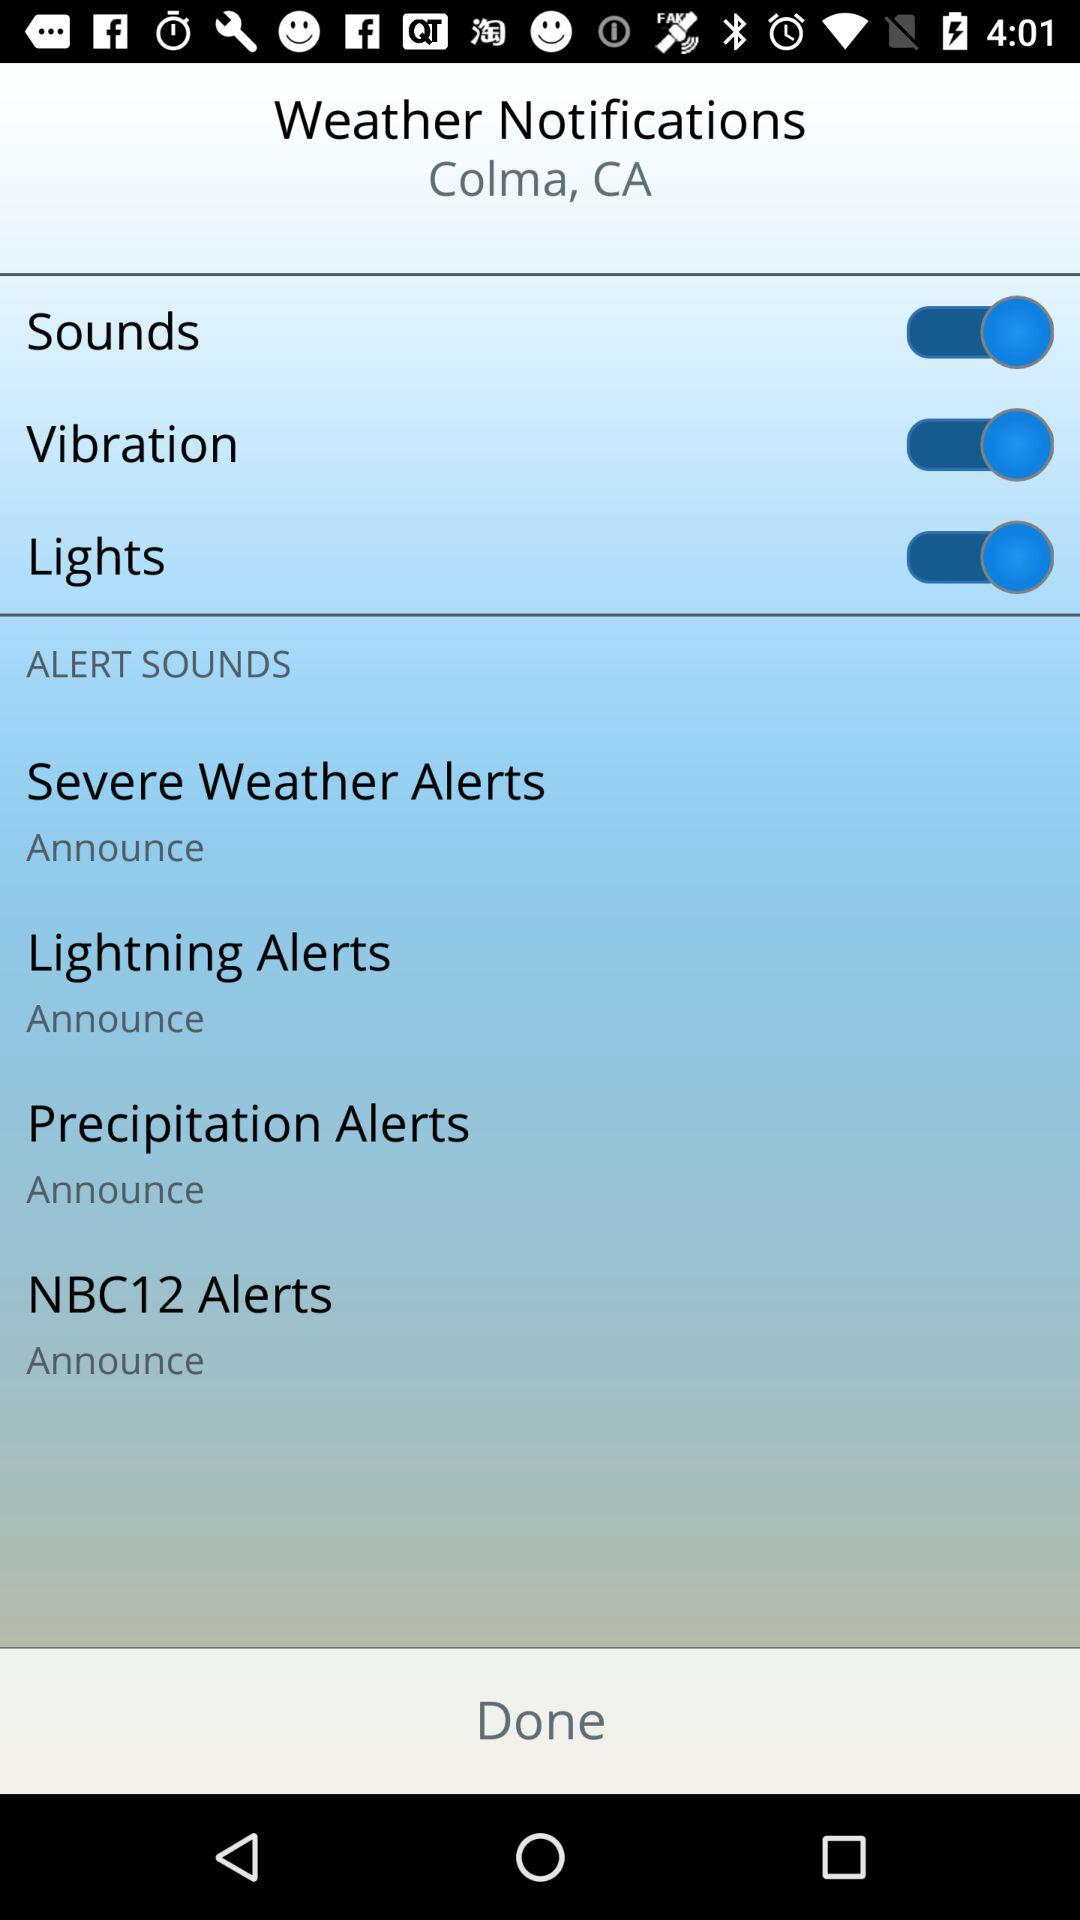What is the setting for the lightning alerts? The setting for the lightning alerts is "Announce". 